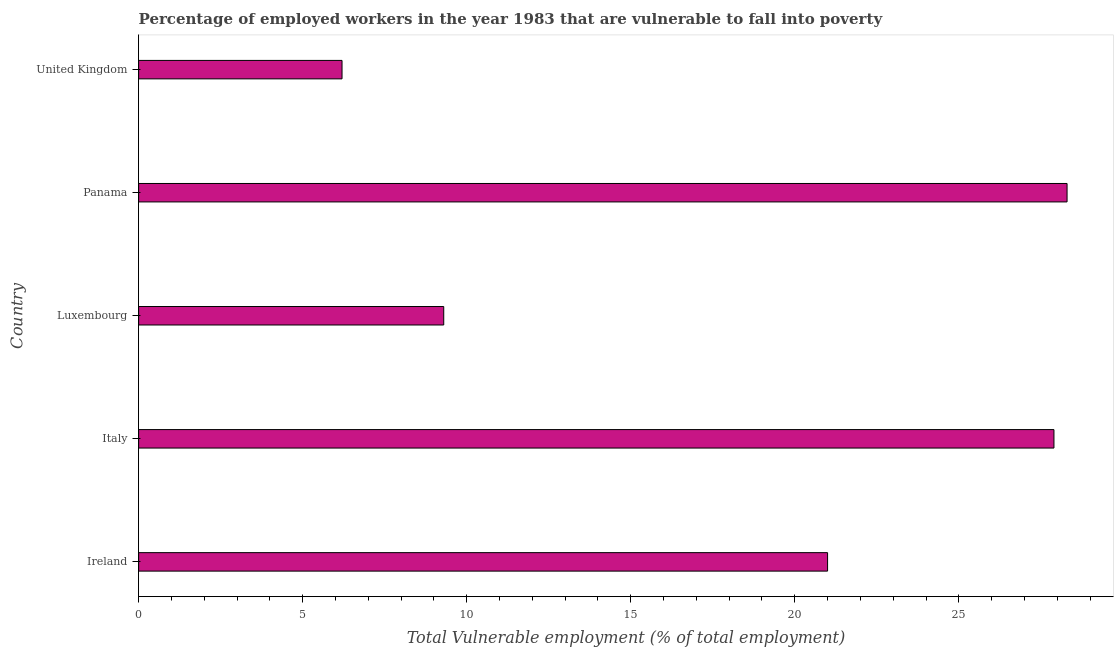Does the graph contain any zero values?
Make the answer very short. No. What is the title of the graph?
Provide a succinct answer. Percentage of employed workers in the year 1983 that are vulnerable to fall into poverty. What is the label or title of the X-axis?
Offer a terse response. Total Vulnerable employment (% of total employment). What is the label or title of the Y-axis?
Give a very brief answer. Country. What is the total vulnerable employment in United Kingdom?
Your answer should be very brief. 6.2. Across all countries, what is the maximum total vulnerable employment?
Make the answer very short. 28.3. Across all countries, what is the minimum total vulnerable employment?
Keep it short and to the point. 6.2. In which country was the total vulnerable employment maximum?
Provide a succinct answer. Panama. What is the sum of the total vulnerable employment?
Provide a short and direct response. 92.7. What is the average total vulnerable employment per country?
Your answer should be compact. 18.54. In how many countries, is the total vulnerable employment greater than 3 %?
Your response must be concise. 5. What is the ratio of the total vulnerable employment in Ireland to that in Panama?
Provide a succinct answer. 0.74. What is the difference between the highest and the second highest total vulnerable employment?
Your answer should be very brief. 0.4. What is the difference between the highest and the lowest total vulnerable employment?
Give a very brief answer. 22.1. Are all the bars in the graph horizontal?
Make the answer very short. Yes. Are the values on the major ticks of X-axis written in scientific E-notation?
Offer a terse response. No. What is the Total Vulnerable employment (% of total employment) in Italy?
Provide a succinct answer. 27.9. What is the Total Vulnerable employment (% of total employment) in Luxembourg?
Provide a succinct answer. 9.3. What is the Total Vulnerable employment (% of total employment) in Panama?
Give a very brief answer. 28.3. What is the Total Vulnerable employment (% of total employment) of United Kingdom?
Offer a very short reply. 6.2. What is the difference between the Total Vulnerable employment (% of total employment) in Ireland and Italy?
Keep it short and to the point. -6.9. What is the difference between the Total Vulnerable employment (% of total employment) in Ireland and Panama?
Your response must be concise. -7.3. What is the difference between the Total Vulnerable employment (% of total employment) in Italy and United Kingdom?
Offer a terse response. 21.7. What is the difference between the Total Vulnerable employment (% of total employment) in Luxembourg and Panama?
Make the answer very short. -19. What is the difference between the Total Vulnerable employment (% of total employment) in Panama and United Kingdom?
Give a very brief answer. 22.1. What is the ratio of the Total Vulnerable employment (% of total employment) in Ireland to that in Italy?
Offer a very short reply. 0.75. What is the ratio of the Total Vulnerable employment (% of total employment) in Ireland to that in Luxembourg?
Provide a succinct answer. 2.26. What is the ratio of the Total Vulnerable employment (% of total employment) in Ireland to that in Panama?
Make the answer very short. 0.74. What is the ratio of the Total Vulnerable employment (% of total employment) in Ireland to that in United Kingdom?
Your answer should be compact. 3.39. What is the ratio of the Total Vulnerable employment (% of total employment) in Italy to that in United Kingdom?
Your response must be concise. 4.5. What is the ratio of the Total Vulnerable employment (% of total employment) in Luxembourg to that in Panama?
Offer a terse response. 0.33. What is the ratio of the Total Vulnerable employment (% of total employment) in Luxembourg to that in United Kingdom?
Ensure brevity in your answer.  1.5. What is the ratio of the Total Vulnerable employment (% of total employment) in Panama to that in United Kingdom?
Provide a short and direct response. 4.57. 